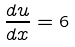Convert formula to latex. <formula><loc_0><loc_0><loc_500><loc_500>\frac { d u } { d x } = 6</formula> 